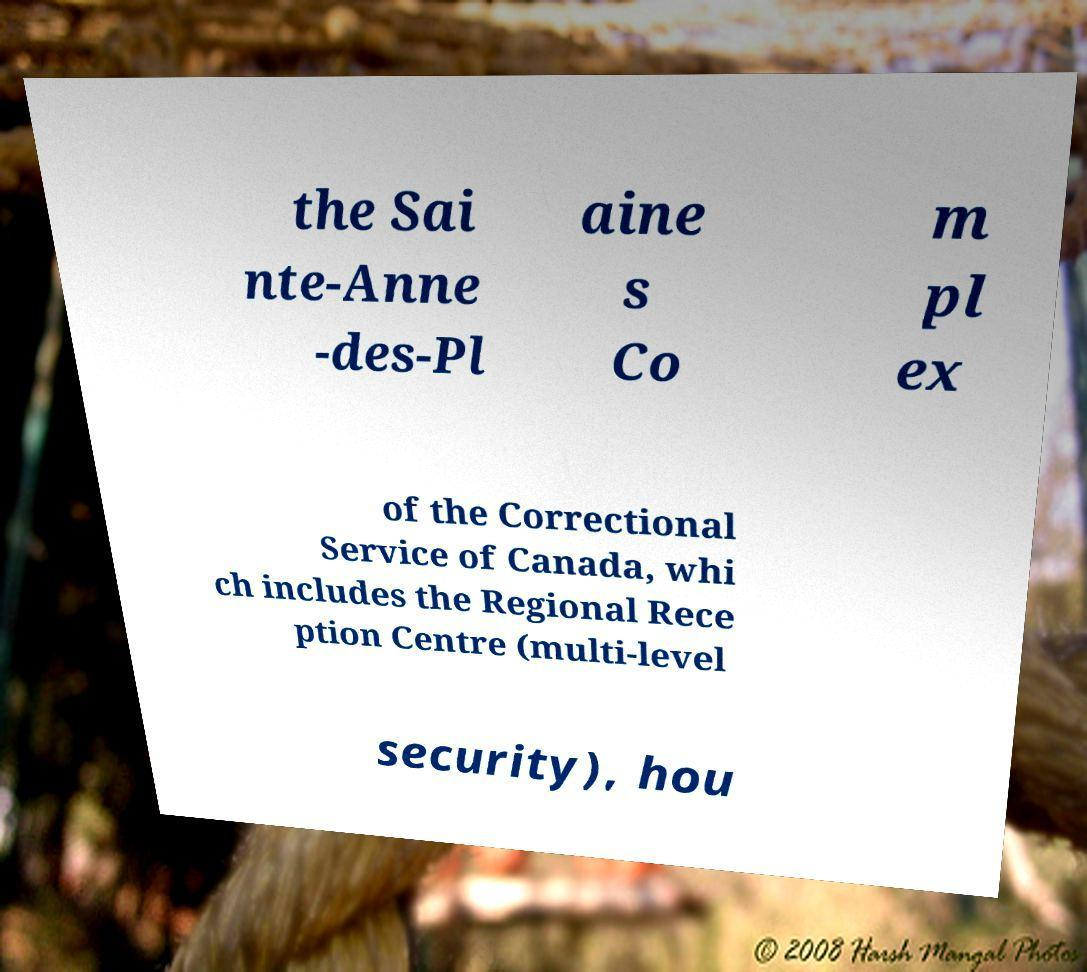There's text embedded in this image that I need extracted. Can you transcribe it verbatim? the Sai nte-Anne -des-Pl aine s Co m pl ex of the Correctional Service of Canada, whi ch includes the Regional Rece ption Centre (multi-level security), hou 